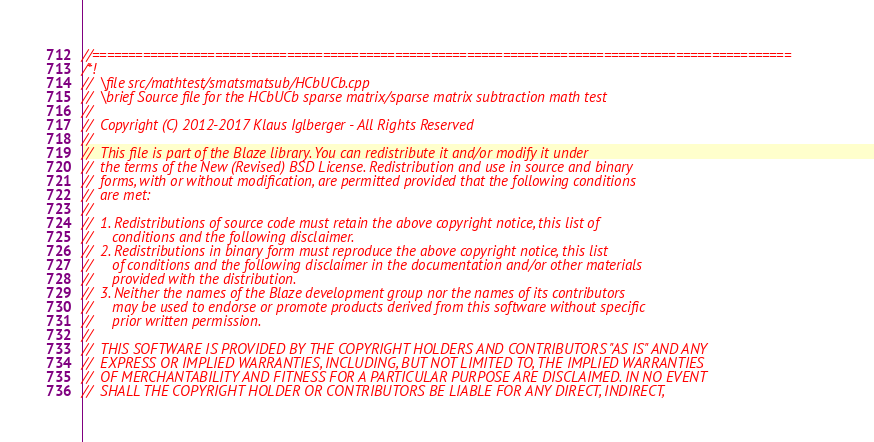Convert code to text. <code><loc_0><loc_0><loc_500><loc_500><_C++_>//=================================================================================================
/*!
//  \file src/mathtest/smatsmatsub/HCbUCb.cpp
//  \brief Source file for the HCbUCb sparse matrix/sparse matrix subtraction math test
//
//  Copyright (C) 2012-2017 Klaus Iglberger - All Rights Reserved
//
//  This file is part of the Blaze library. You can redistribute it and/or modify it under
//  the terms of the New (Revised) BSD License. Redistribution and use in source and binary
//  forms, with or without modification, are permitted provided that the following conditions
//  are met:
//
//  1. Redistributions of source code must retain the above copyright notice, this list of
//     conditions and the following disclaimer.
//  2. Redistributions in binary form must reproduce the above copyright notice, this list
//     of conditions and the following disclaimer in the documentation and/or other materials
//     provided with the distribution.
//  3. Neither the names of the Blaze development group nor the names of its contributors
//     may be used to endorse or promote products derived from this software without specific
//     prior written permission.
//
//  THIS SOFTWARE IS PROVIDED BY THE COPYRIGHT HOLDERS AND CONTRIBUTORS "AS IS" AND ANY
//  EXPRESS OR IMPLIED WARRANTIES, INCLUDING, BUT NOT LIMITED TO, THE IMPLIED WARRANTIES
//  OF MERCHANTABILITY AND FITNESS FOR A PARTICULAR PURPOSE ARE DISCLAIMED. IN NO EVENT
//  SHALL THE COPYRIGHT HOLDER OR CONTRIBUTORS BE LIABLE FOR ANY DIRECT, INDIRECT,</code> 